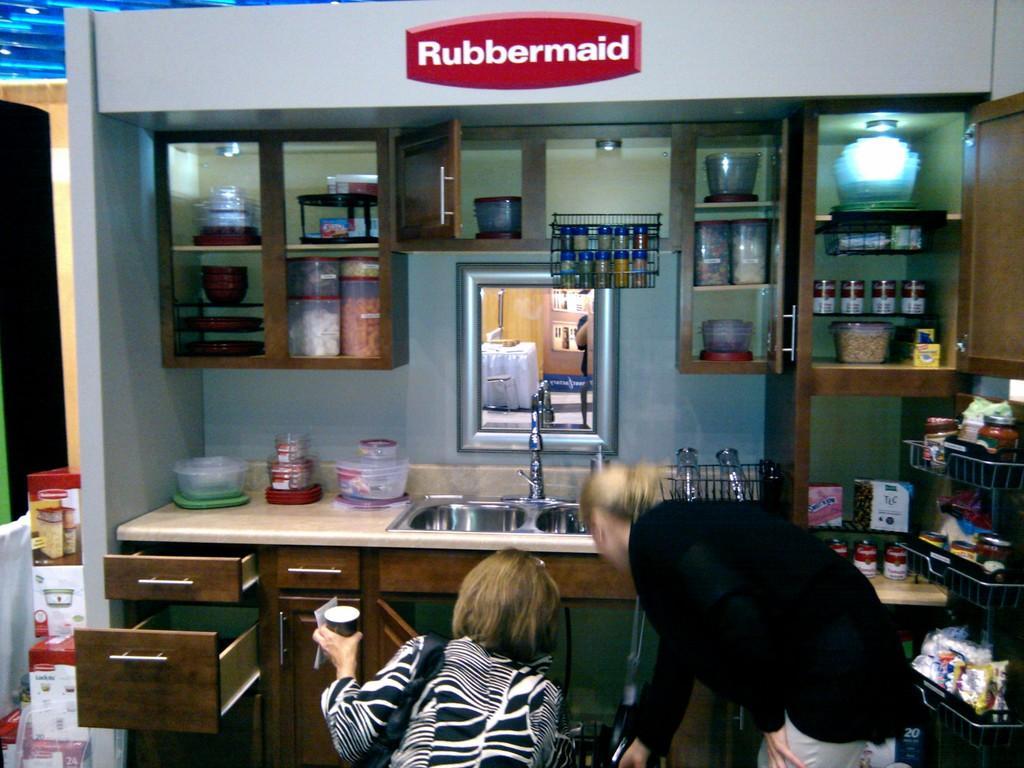In one or two sentences, can you explain what this image depicts? There are two people bending on their legs and looking at something and there are kitchen groceries,a mirror and wash basin in the background. 